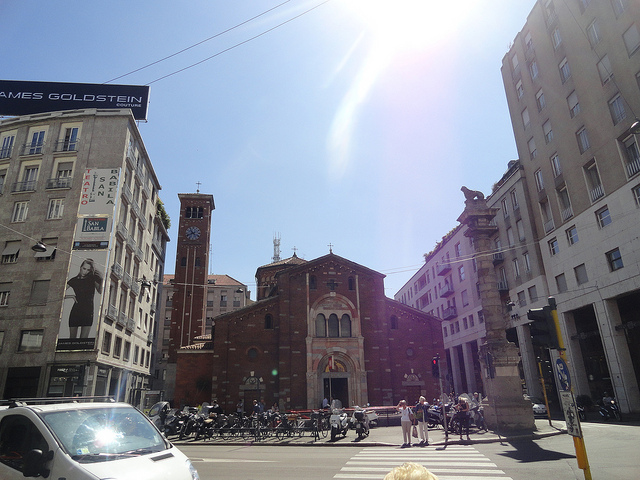<image>What is the theater straight ahead? It is ambiguous what the theater straight ahead is. It could be a church, a movie theater, or something else. What is the theater straight ahead? I don't know what theater is straight ahead. It can be the Fox theater, a church, a movie theater, or something else. 